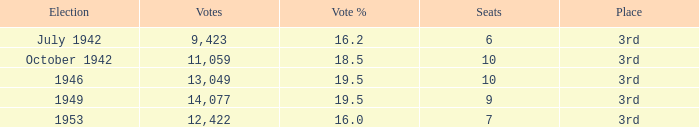Name the vote % for seats of 9 19.5. 